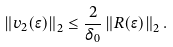<formula> <loc_0><loc_0><loc_500><loc_500>\left \| v _ { 2 } ( \epsilon ) \right \| _ { 2 } \leq \frac { 2 } { \delta _ { 0 } } \left \| R ( \epsilon ) \right \| _ { 2 } .</formula> 